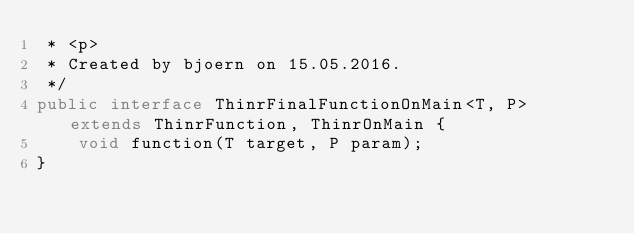Convert code to text. <code><loc_0><loc_0><loc_500><loc_500><_Java_> * <p>
 * Created by bjoern on 15.05.2016.
 */
public interface ThinrFinalFunctionOnMain<T, P> extends ThinrFunction, ThinrOnMain {
    void function(T target, P param);
}
</code> 